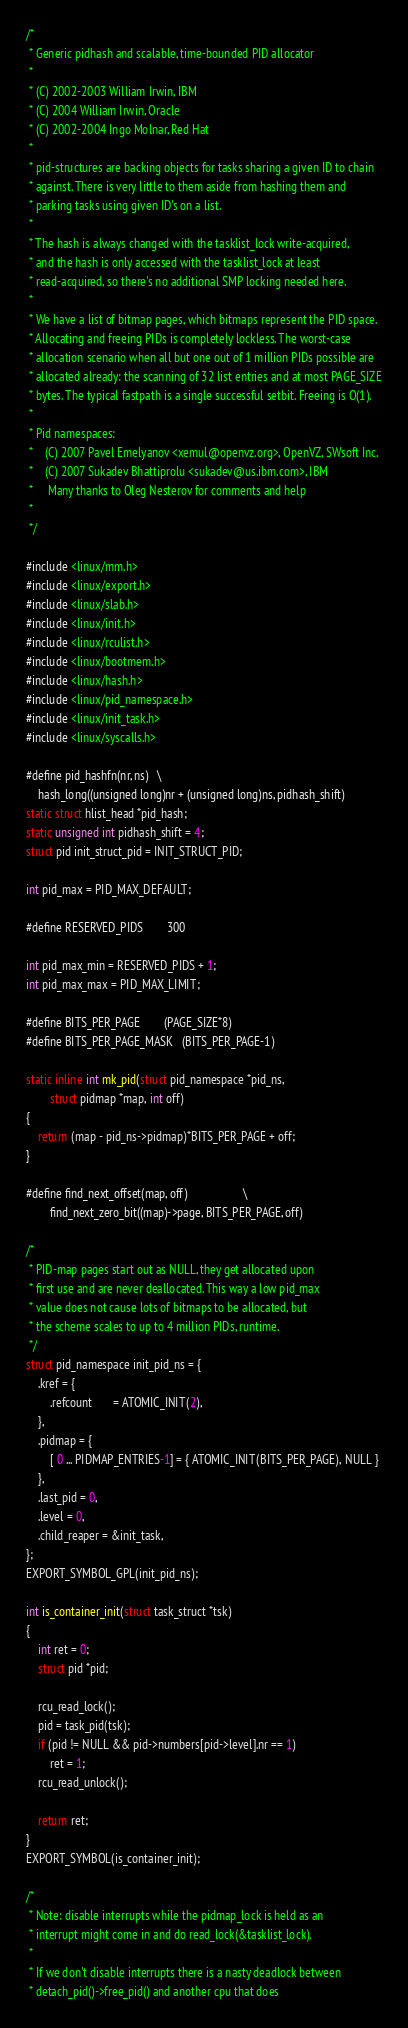<code> <loc_0><loc_0><loc_500><loc_500><_C_>/*
 * Generic pidhash and scalable, time-bounded PID allocator
 *
 * (C) 2002-2003 William Irwin, IBM
 * (C) 2004 William Irwin, Oracle
 * (C) 2002-2004 Ingo Molnar, Red Hat
 *
 * pid-structures are backing objects for tasks sharing a given ID to chain
 * against. There is very little to them aside from hashing them and
 * parking tasks using given ID's on a list.
 *
 * The hash is always changed with the tasklist_lock write-acquired,
 * and the hash is only accessed with the tasklist_lock at least
 * read-acquired, so there's no additional SMP locking needed here.
 *
 * We have a list of bitmap pages, which bitmaps represent the PID space.
 * Allocating and freeing PIDs is completely lockless. The worst-case
 * allocation scenario when all but one out of 1 million PIDs possible are
 * allocated already: the scanning of 32 list entries and at most PAGE_SIZE
 * bytes. The typical fastpath is a single successful setbit. Freeing is O(1).
 *
 * Pid namespaces:
 *    (C) 2007 Pavel Emelyanov <xemul@openvz.org>, OpenVZ, SWsoft Inc.
 *    (C) 2007 Sukadev Bhattiprolu <sukadev@us.ibm.com>, IBM
 *     Many thanks to Oleg Nesterov for comments and help
 *
 */

#include <linux/mm.h>
#include <linux/export.h>
#include <linux/slab.h>
#include <linux/init.h>
#include <linux/rculist.h>
#include <linux/bootmem.h>
#include <linux/hash.h>
#include <linux/pid_namespace.h>
#include <linux/init_task.h>
#include <linux/syscalls.h>

#define pid_hashfn(nr, ns)	\
	hash_long((unsigned long)nr + (unsigned long)ns, pidhash_shift)
static struct hlist_head *pid_hash;
static unsigned int pidhash_shift = 4;
struct pid init_struct_pid = INIT_STRUCT_PID;

int pid_max = PID_MAX_DEFAULT;

#define RESERVED_PIDS		300

int pid_max_min = RESERVED_PIDS + 1;
int pid_max_max = PID_MAX_LIMIT;

#define BITS_PER_PAGE		(PAGE_SIZE*8)
#define BITS_PER_PAGE_MASK	(BITS_PER_PAGE-1)

static inline int mk_pid(struct pid_namespace *pid_ns,
		struct pidmap *map, int off)
{
	return (map - pid_ns->pidmap)*BITS_PER_PAGE + off;
}

#define find_next_offset(map, off)					\
		find_next_zero_bit((map)->page, BITS_PER_PAGE, off)

/*
 * PID-map pages start out as NULL, they get allocated upon
 * first use and are never deallocated. This way a low pid_max
 * value does not cause lots of bitmaps to be allocated, but
 * the scheme scales to up to 4 million PIDs, runtime.
 */
struct pid_namespace init_pid_ns = {
	.kref = {
		.refcount       = ATOMIC_INIT(2),
	},
	.pidmap = {
		[ 0 ... PIDMAP_ENTRIES-1] = { ATOMIC_INIT(BITS_PER_PAGE), NULL }
	},
	.last_pid = 0,
	.level = 0,
	.child_reaper = &init_task,
};
EXPORT_SYMBOL_GPL(init_pid_ns);

int is_container_init(struct task_struct *tsk)
{
	int ret = 0;
	struct pid *pid;

	rcu_read_lock();
	pid = task_pid(tsk);
	if (pid != NULL && pid->numbers[pid->level].nr == 1)
		ret = 1;
	rcu_read_unlock();

	return ret;
}
EXPORT_SYMBOL(is_container_init);

/*
 * Note: disable interrupts while the pidmap_lock is held as an
 * interrupt might come in and do read_lock(&tasklist_lock).
 *
 * If we don't disable interrupts there is a nasty deadlock between
 * detach_pid()->free_pid() and another cpu that does</code> 